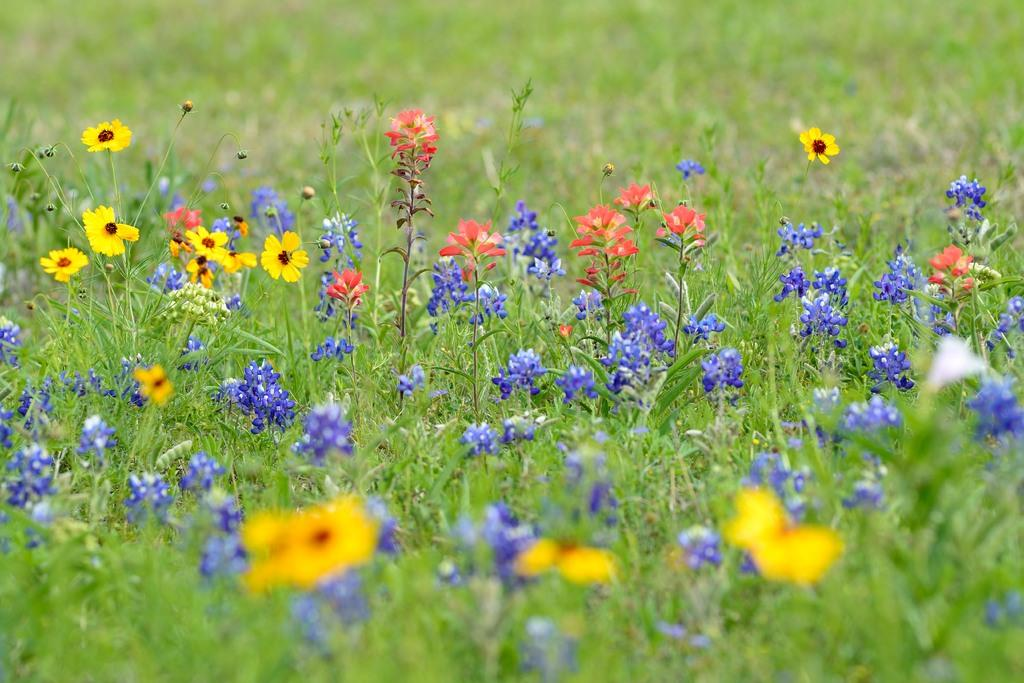What type of living organisms can be seen in the image? Plants and flowers can be seen in the image. Can you describe the specific features of the plants in the image? The plants in the image have flowers. What type of cloud can be seen in the image? There is no cloud present in the image; it features plants and flowers. Is there a guitar visible in the image? There is no guitar present in the image. 